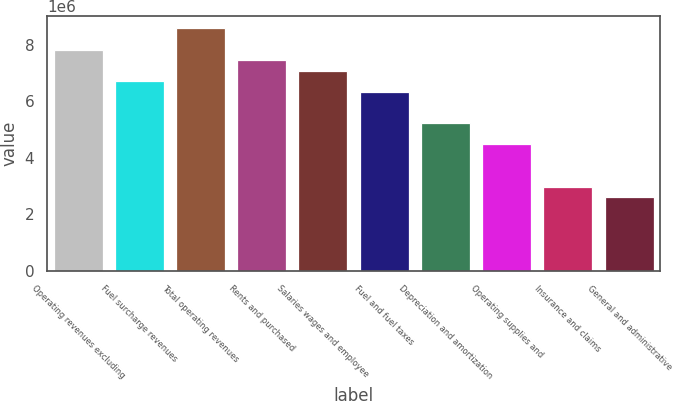<chart> <loc_0><loc_0><loc_500><loc_500><bar_chart><fcel>Operating revenues excluding<fcel>Fuel surcharge revenues<fcel>Total operating revenues<fcel>Rents and purchased<fcel>Salaries wages and employee<fcel>Fuel and fuel taxes<fcel>Depreciation and amortization<fcel>Operating supplies and<fcel>Insurance and claims<fcel>General and administrative<nl><fcel>7.83708e+06<fcel>6.7175e+06<fcel>8.58347e+06<fcel>7.46389e+06<fcel>7.09069e+06<fcel>6.3443e+06<fcel>5.22472e+06<fcel>4.47833e+06<fcel>2.98555e+06<fcel>2.61236e+06<nl></chart> 